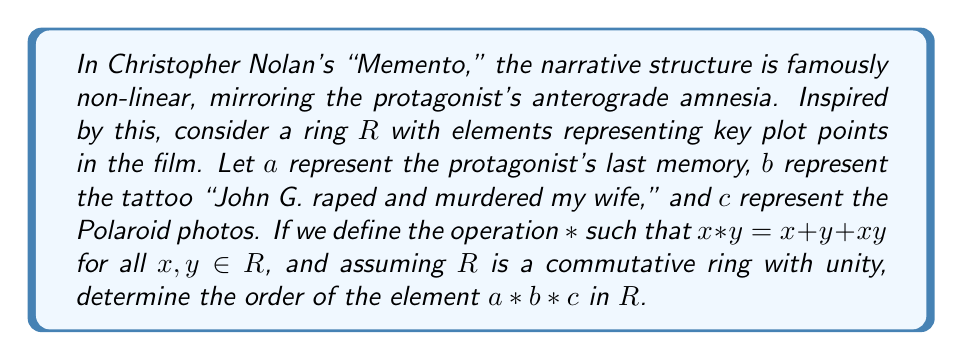What is the answer to this math problem? To solve this problem, we need to follow these steps:

1) First, let's calculate $a * b * c$:

   $a * b = a + b + ab$
   $(a * b) * c = (a + b + ab) + c + (a + b + ab)c$
                $= a + b + c + ab + ac + bc + abc$

2) Now, we need to find the smallest positive integer $n$ such that $(a * b * c)^n = e$, where $e$ is the identity element of the ring under multiplication.

3) Let's expand $(a * b * c)^2$:

   $$(a * b * c)^2 = (a + b + c + ab + ac + bc + abc)^2$$
   $$= a^2 + b^2 + c^2 + (ab)^2 + (ac)^2 + (bc)^2 + (abc)^2 + \text{mixed terms}$$

4) In a ring, $(x + y)^2 = x^2 + 2xy + y^2$. However, in our case, we don't know if $2 = 0$ in this ring or not.

5) Without more information about the specific properties of this ring, we cannot determine the exact order of $a * b * c$.

6) However, we can make an interesting observation: just as the narrative in "Memento" loops back on itself, the element $a * b * c$ could potentially have an order that creates a cyclical pattern in the ring, mirroring the film's structure.

7) The order could be finite (like the finite number of scenes in the movie) or infinite (like the endless loop of the protagonist's condition).
Answer: Without more specific information about the ring $R$, it's not possible to determine the exact order of $a * b * c$. The order could be finite or infinite, depending on the properties of $R$ and the specific values of $a$, $b$, and $c$. 